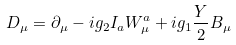<formula> <loc_0><loc_0><loc_500><loc_500>D _ { \mu } = \partial _ { \mu } - i g _ { 2 } I _ { a } W _ { \mu } ^ { a } + i g _ { 1 } \frac { Y } { 2 } B _ { \mu }</formula> 